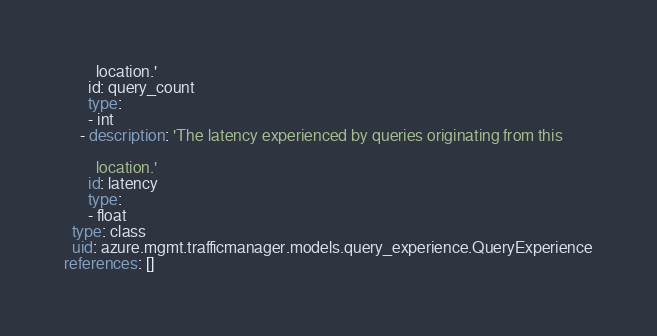Convert code to text. <code><loc_0><loc_0><loc_500><loc_500><_YAML_>
        location.'
      id: query_count
      type:
      - int
    - description: 'The latency experienced by queries originating from this

        location.'
      id: latency
      type:
      - float
  type: class
  uid: azure.mgmt.trafficmanager.models.query_experience.QueryExperience
references: []
</code> 